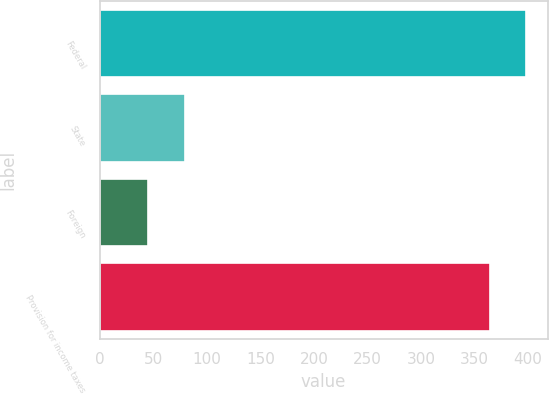Convert chart to OTSL. <chart><loc_0><loc_0><loc_500><loc_500><bar_chart><fcel>Federal<fcel>State<fcel>Foreign<fcel>Provision for income taxes<nl><fcel>398.4<fcel>79.4<fcel>45<fcel>364<nl></chart> 